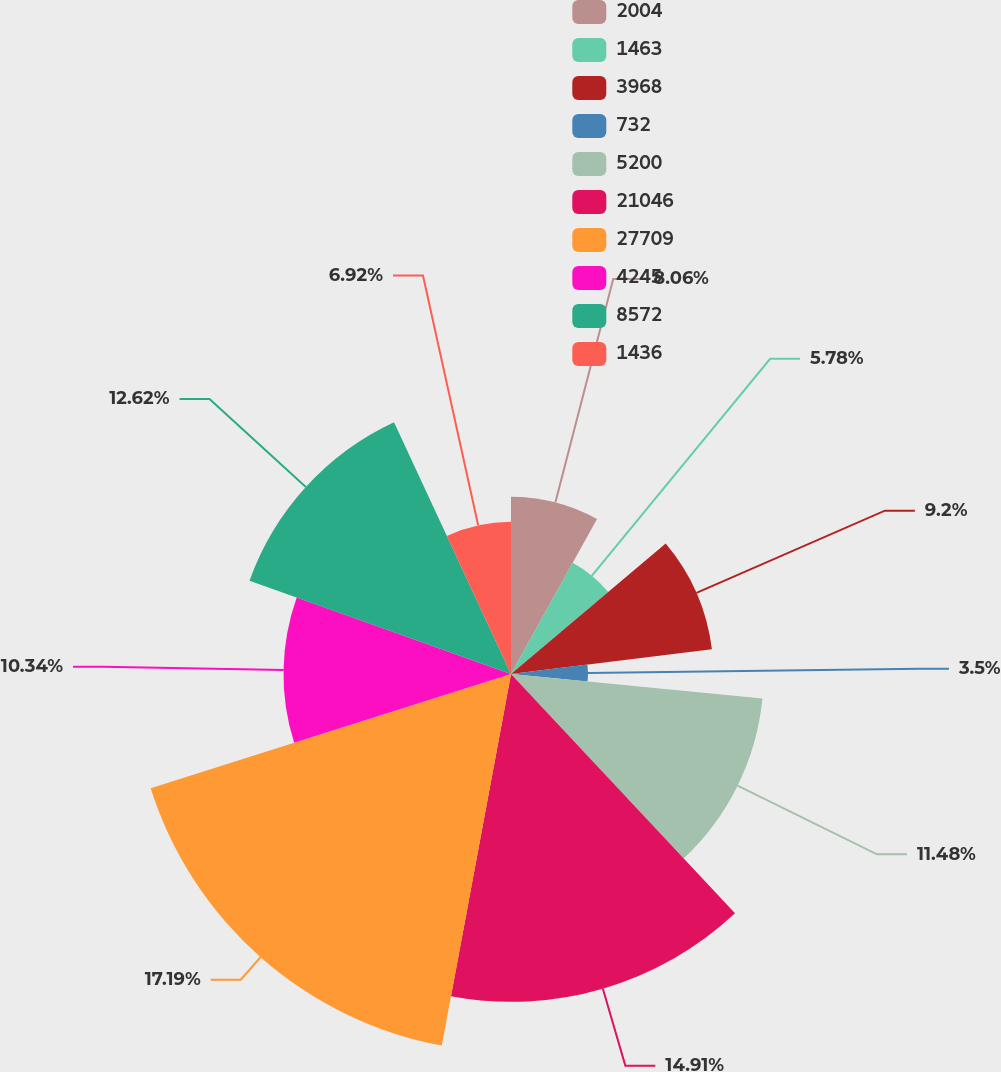Convert chart to OTSL. <chart><loc_0><loc_0><loc_500><loc_500><pie_chart><fcel>2004<fcel>1463<fcel>3968<fcel>732<fcel>5200<fcel>21046<fcel>27709<fcel>4245<fcel>8572<fcel>1436<nl><fcel>8.06%<fcel>5.78%<fcel>9.2%<fcel>3.5%<fcel>11.48%<fcel>14.9%<fcel>17.18%<fcel>10.34%<fcel>12.62%<fcel>6.92%<nl></chart> 